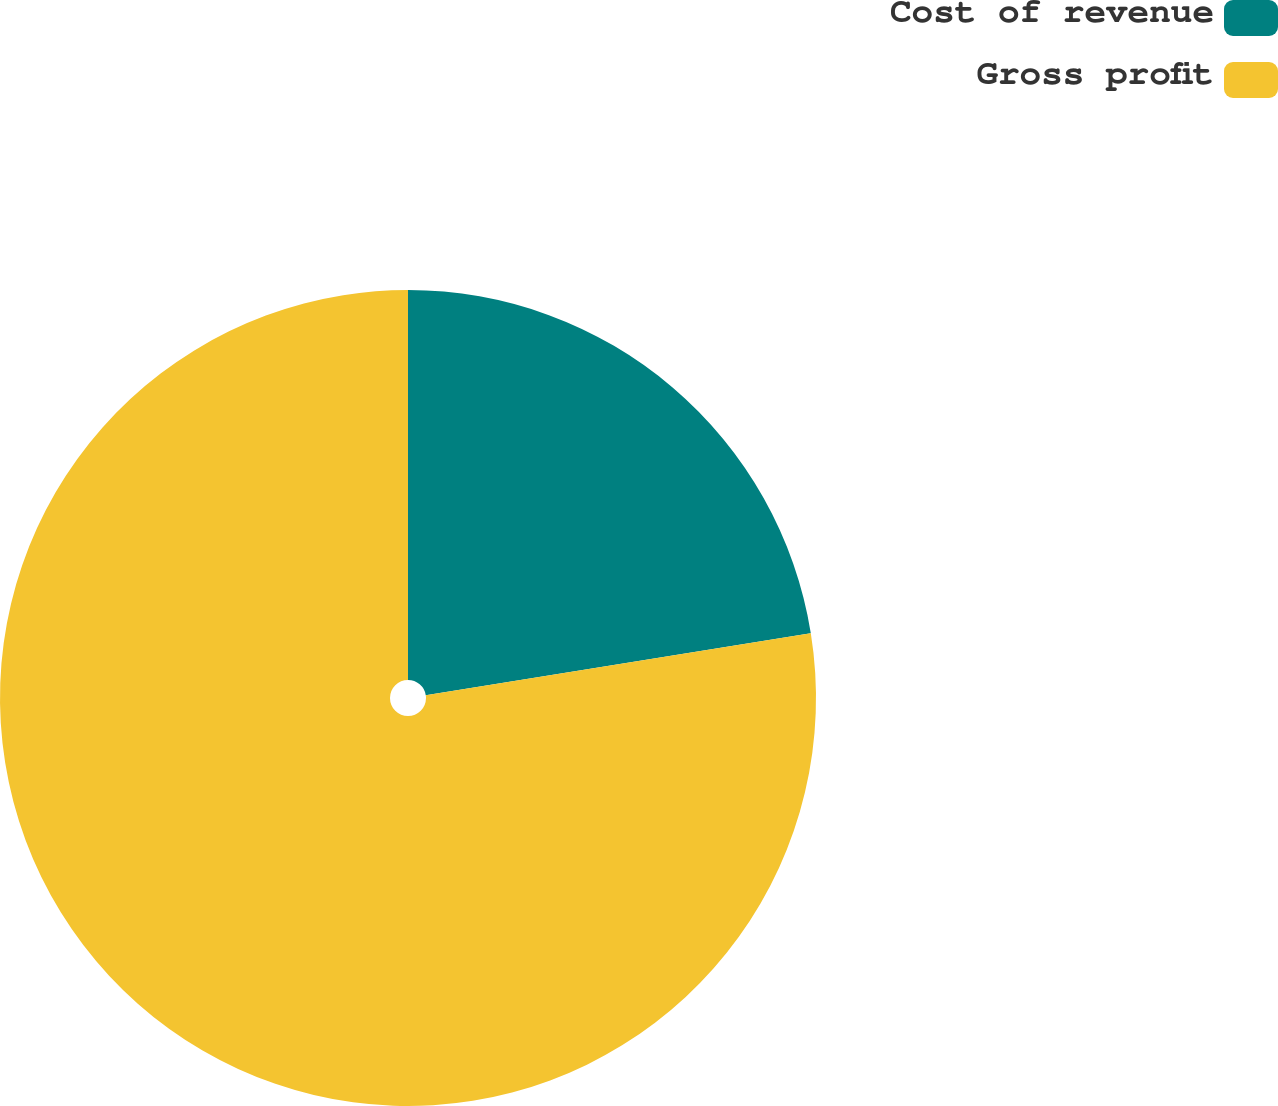Convert chart to OTSL. <chart><loc_0><loc_0><loc_500><loc_500><pie_chart><fcel>Cost of revenue<fcel>Gross profit<nl><fcel>22.46%<fcel>77.54%<nl></chart> 